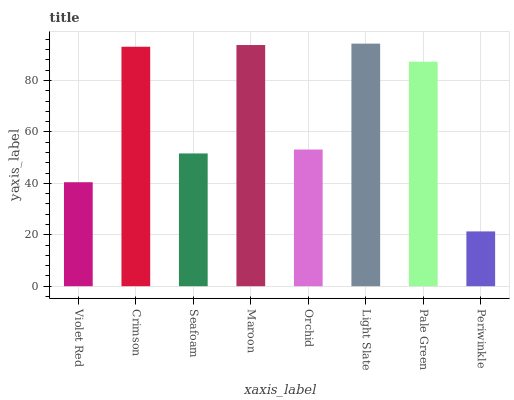Is Periwinkle the minimum?
Answer yes or no. Yes. Is Light Slate the maximum?
Answer yes or no. Yes. Is Crimson the minimum?
Answer yes or no. No. Is Crimson the maximum?
Answer yes or no. No. Is Crimson greater than Violet Red?
Answer yes or no. Yes. Is Violet Red less than Crimson?
Answer yes or no. Yes. Is Violet Red greater than Crimson?
Answer yes or no. No. Is Crimson less than Violet Red?
Answer yes or no. No. Is Pale Green the high median?
Answer yes or no. Yes. Is Orchid the low median?
Answer yes or no. Yes. Is Light Slate the high median?
Answer yes or no. No. Is Periwinkle the low median?
Answer yes or no. No. 